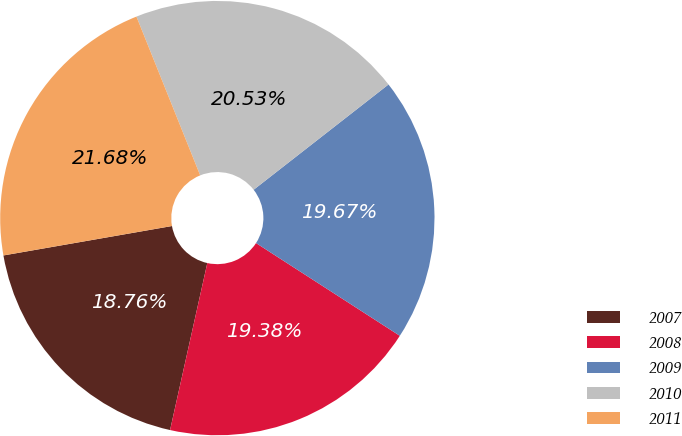Convert chart to OTSL. <chart><loc_0><loc_0><loc_500><loc_500><pie_chart><fcel>2007<fcel>2008<fcel>2009<fcel>2010<fcel>2011<nl><fcel>18.76%<fcel>19.38%<fcel>19.67%<fcel>20.53%<fcel>21.68%<nl></chart> 